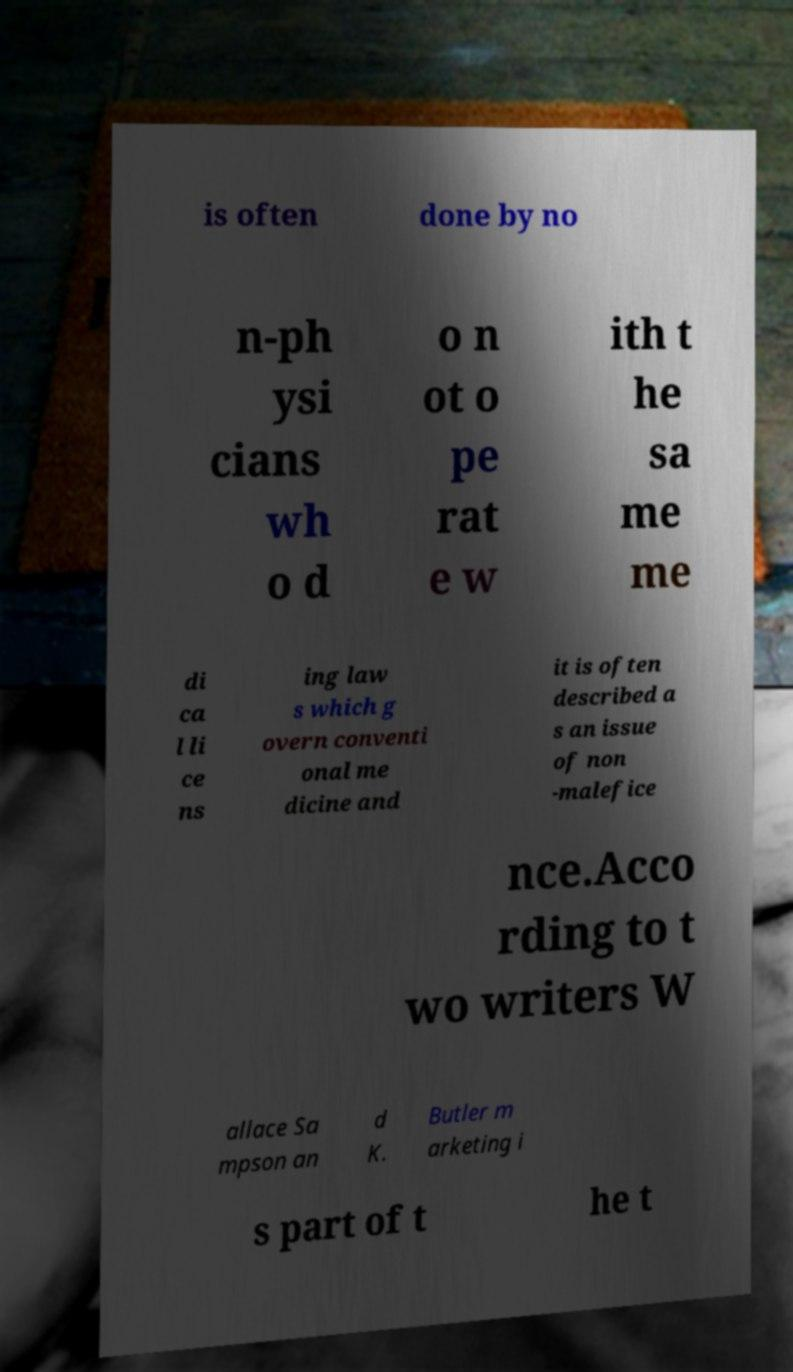Can you accurately transcribe the text from the provided image for me? is often done by no n-ph ysi cians wh o d o n ot o pe rat e w ith t he sa me me di ca l li ce ns ing law s which g overn conventi onal me dicine and it is often described a s an issue of non -malefice nce.Acco rding to t wo writers W allace Sa mpson an d K. Butler m arketing i s part of t he t 